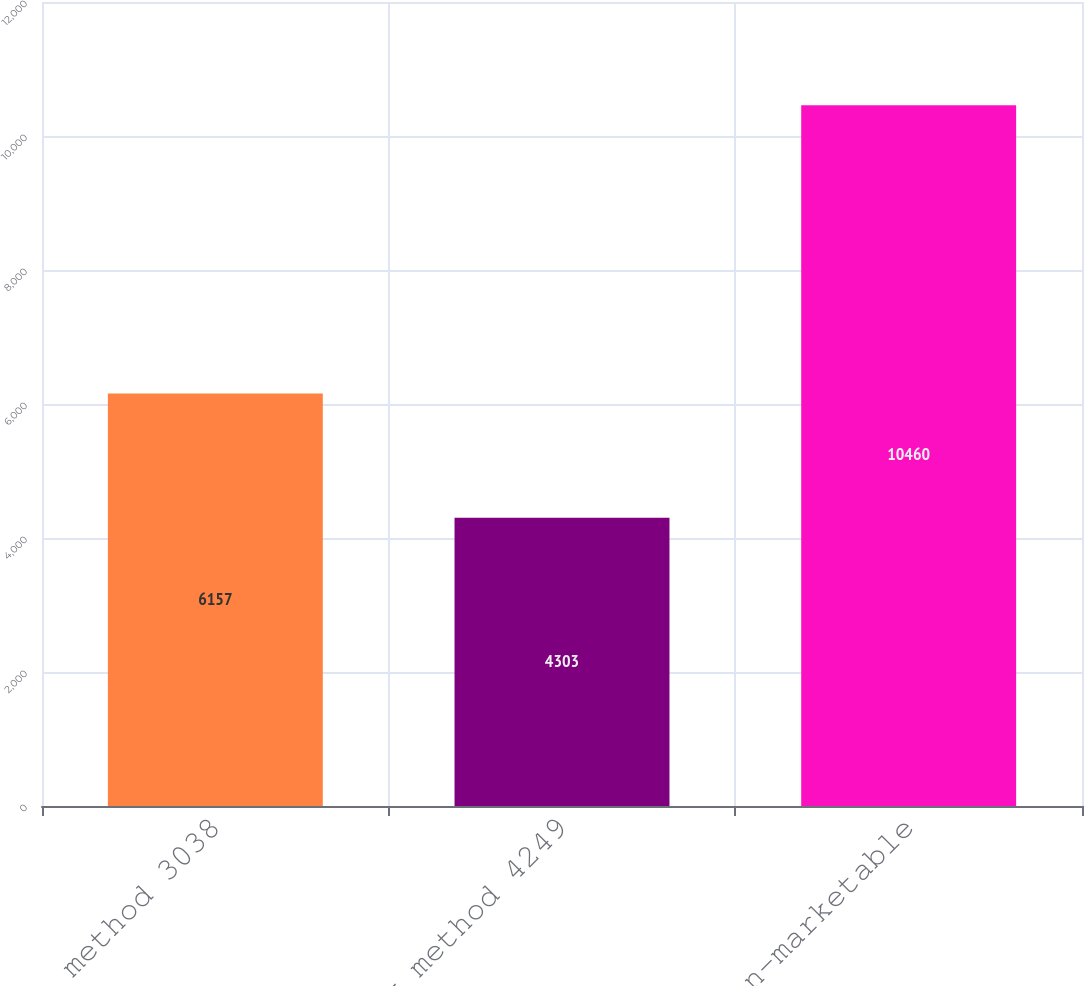Convert chart. <chart><loc_0><loc_0><loc_500><loc_500><bar_chart><fcel>Cost method 3038<fcel>Equity method 4249<fcel>Total non-marketable<nl><fcel>6157<fcel>4303<fcel>10460<nl></chart> 